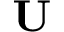Convert formula to latex. <formula><loc_0><loc_0><loc_500><loc_500>U</formula> 